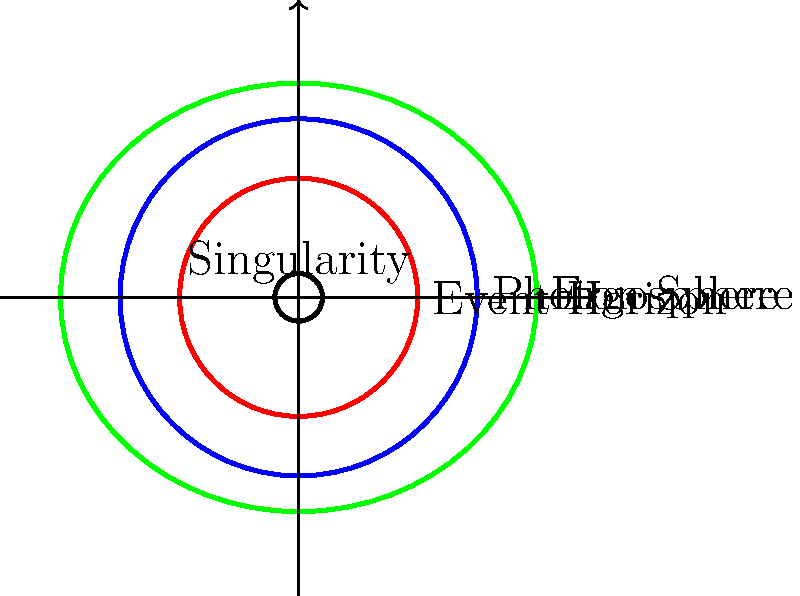In this cross-sectional diagram of a rotating black hole, which region would be most relevant to a science fiction story about a spacecraft trying to extract energy from the black hole without crossing the event horizon? To answer this question, let's analyze the different regions of a rotating black hole:

1. Singularity: The central point of infinite density where the laws of physics break down.
2. Event Horizon: The boundary beyond which nothing can escape the black hole's gravitational pull.
3. Photon Sphere: A region where photons can orbit the black hole in a circular path.
4. Ergosphere: A region outside the event horizon where space-time is dragged along with the black hole's rotation.

For a science fiction story about extracting energy without crossing the event horizon, the most relevant region would be the ergosphere. This is because:

1. The ergosphere is outside the event horizon, so a spacecraft could theoretically enter and exit this region.
2. In the ergosphere, objects can still escape the black hole, unlike beyond the event horizon.
3. The ergosphere's unique properties allow for the possibility of energy extraction through a process called the Penrose process.

The Penrose process, proposed by Roger Penrose in 1969, suggests that it's theoretically possible to extract energy from a rotating black hole by sending an object into the ergosphere, splitting it, and allowing one part to fall into the black hole while the other escapes with more energy than the original object.

This concept would provide a fascinating backdrop for a science fiction story, as it combines real astrophysical theory with the speculative possibility of advanced technology capable of harnessing such extreme cosmic phenomena.
Answer: Ergosphere 